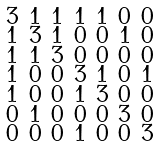<formula> <loc_0><loc_0><loc_500><loc_500>\begin{smallmatrix} 3 & 1 & 1 & 1 & 1 & 0 & 0 \\ 1 & 3 & 1 & 0 & 0 & 1 & 0 \\ 1 & 1 & 3 & 0 & 0 & 0 & 0 \\ 1 & 0 & 0 & 3 & 1 & 0 & 1 \\ 1 & 0 & 0 & 1 & 3 & 0 & 0 \\ 0 & 1 & 0 & 0 & 0 & 3 & 0 \\ 0 & 0 & 0 & 1 & 0 & 0 & 3 \end{smallmatrix}</formula> 